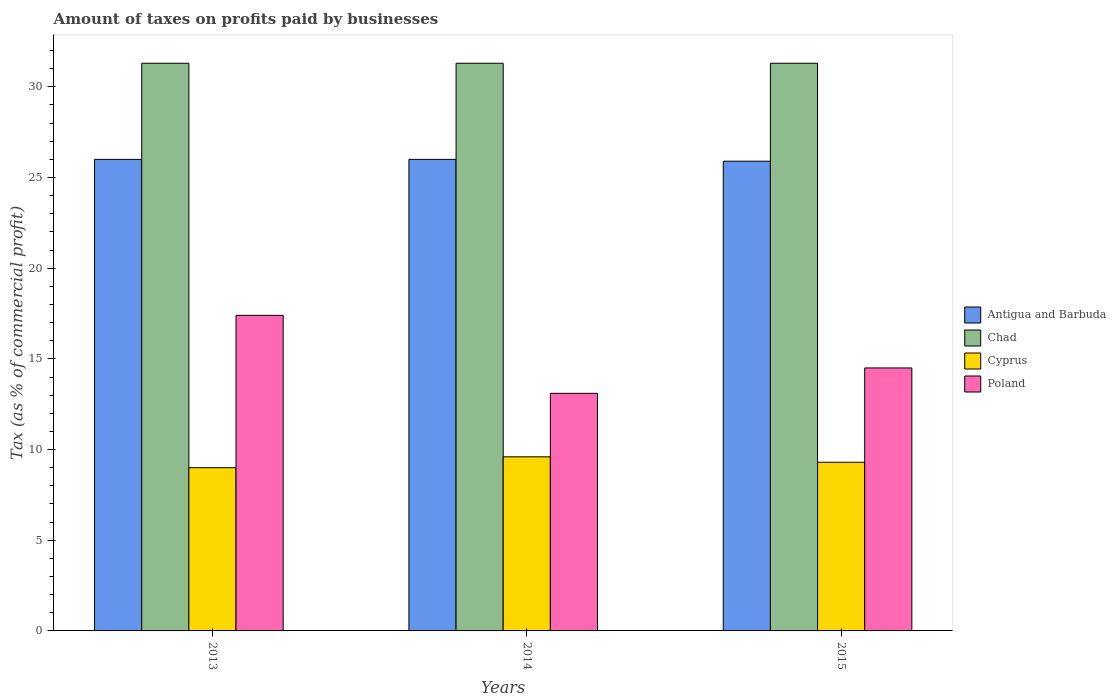How many different coloured bars are there?
Your response must be concise. 4. How many groups of bars are there?
Your answer should be very brief. 3. How many bars are there on the 1st tick from the left?
Offer a terse response. 4. How many bars are there on the 3rd tick from the right?
Offer a very short reply. 4. What is the label of the 2nd group of bars from the left?
Give a very brief answer. 2014. Across all years, what is the maximum percentage of taxes paid by businesses in Chad?
Offer a very short reply. 31.3. Across all years, what is the minimum percentage of taxes paid by businesses in Cyprus?
Provide a short and direct response. 9. In which year was the percentage of taxes paid by businesses in Chad maximum?
Give a very brief answer. 2013. In which year was the percentage of taxes paid by businesses in Cyprus minimum?
Your response must be concise. 2013. What is the total percentage of taxes paid by businesses in Cyprus in the graph?
Provide a succinct answer. 27.9. What is the difference between the percentage of taxes paid by businesses in Poland in 2013 and that in 2015?
Your answer should be very brief. 2.9. What is the difference between the percentage of taxes paid by businesses in Cyprus in 2015 and the percentage of taxes paid by businesses in Antigua and Barbuda in 2014?
Provide a short and direct response. -16.7. What is the average percentage of taxes paid by businesses in Antigua and Barbuda per year?
Ensure brevity in your answer.  25.97. In the year 2013, what is the difference between the percentage of taxes paid by businesses in Cyprus and percentage of taxes paid by businesses in Chad?
Provide a short and direct response. -22.3. In how many years, is the percentage of taxes paid by businesses in Chad greater than 19 %?
Keep it short and to the point. 3. Is the percentage of taxes paid by businesses in Cyprus in 2014 less than that in 2015?
Your answer should be very brief. No. Is the difference between the percentage of taxes paid by businesses in Cyprus in 2013 and 2015 greater than the difference between the percentage of taxes paid by businesses in Chad in 2013 and 2015?
Provide a succinct answer. No. What is the difference between the highest and the second highest percentage of taxes paid by businesses in Cyprus?
Your response must be concise. 0.3. What is the difference between the highest and the lowest percentage of taxes paid by businesses in Cyprus?
Offer a terse response. 0.6. In how many years, is the percentage of taxes paid by businesses in Cyprus greater than the average percentage of taxes paid by businesses in Cyprus taken over all years?
Provide a short and direct response. 1. Is the sum of the percentage of taxes paid by businesses in Antigua and Barbuda in 2014 and 2015 greater than the maximum percentage of taxes paid by businesses in Poland across all years?
Your answer should be compact. Yes. Is it the case that in every year, the sum of the percentage of taxes paid by businesses in Poland and percentage of taxes paid by businesses in Antigua and Barbuda is greater than the sum of percentage of taxes paid by businesses in Chad and percentage of taxes paid by businesses in Cyprus?
Give a very brief answer. No. What does the 2nd bar from the left in 2013 represents?
Offer a very short reply. Chad. What does the 1st bar from the right in 2015 represents?
Provide a short and direct response. Poland. Is it the case that in every year, the sum of the percentage of taxes paid by businesses in Poland and percentage of taxes paid by businesses in Chad is greater than the percentage of taxes paid by businesses in Cyprus?
Your answer should be compact. Yes. How many bars are there?
Your answer should be very brief. 12. What is the difference between two consecutive major ticks on the Y-axis?
Offer a terse response. 5. Are the values on the major ticks of Y-axis written in scientific E-notation?
Keep it short and to the point. No. Where does the legend appear in the graph?
Give a very brief answer. Center right. What is the title of the graph?
Ensure brevity in your answer.  Amount of taxes on profits paid by businesses. Does "Turks and Caicos Islands" appear as one of the legend labels in the graph?
Your answer should be compact. No. What is the label or title of the X-axis?
Your response must be concise. Years. What is the label or title of the Y-axis?
Provide a short and direct response. Tax (as % of commercial profit). What is the Tax (as % of commercial profit) of Chad in 2013?
Provide a succinct answer. 31.3. What is the Tax (as % of commercial profit) of Poland in 2013?
Keep it short and to the point. 17.4. What is the Tax (as % of commercial profit) of Chad in 2014?
Your answer should be very brief. 31.3. What is the Tax (as % of commercial profit) of Cyprus in 2014?
Your answer should be compact. 9.6. What is the Tax (as % of commercial profit) of Antigua and Barbuda in 2015?
Your answer should be compact. 25.9. What is the Tax (as % of commercial profit) of Chad in 2015?
Give a very brief answer. 31.3. What is the Tax (as % of commercial profit) in Cyprus in 2015?
Offer a terse response. 9.3. Across all years, what is the maximum Tax (as % of commercial profit) of Chad?
Give a very brief answer. 31.3. Across all years, what is the maximum Tax (as % of commercial profit) of Cyprus?
Offer a very short reply. 9.6. Across all years, what is the minimum Tax (as % of commercial profit) of Antigua and Barbuda?
Offer a terse response. 25.9. Across all years, what is the minimum Tax (as % of commercial profit) of Chad?
Offer a terse response. 31.3. Across all years, what is the minimum Tax (as % of commercial profit) of Poland?
Your answer should be very brief. 13.1. What is the total Tax (as % of commercial profit) in Antigua and Barbuda in the graph?
Your response must be concise. 77.9. What is the total Tax (as % of commercial profit) in Chad in the graph?
Offer a terse response. 93.9. What is the total Tax (as % of commercial profit) in Cyprus in the graph?
Provide a short and direct response. 27.9. What is the difference between the Tax (as % of commercial profit) of Chad in 2013 and that in 2014?
Your answer should be very brief. 0. What is the difference between the Tax (as % of commercial profit) in Antigua and Barbuda in 2013 and that in 2015?
Your answer should be very brief. 0.1. What is the difference between the Tax (as % of commercial profit) of Chad in 2013 and that in 2015?
Your answer should be compact. 0. What is the difference between the Tax (as % of commercial profit) of Cyprus in 2013 and that in 2015?
Make the answer very short. -0.3. What is the difference between the Tax (as % of commercial profit) in Antigua and Barbuda in 2014 and that in 2015?
Offer a very short reply. 0.1. What is the difference between the Tax (as % of commercial profit) of Cyprus in 2014 and that in 2015?
Provide a short and direct response. 0.3. What is the difference between the Tax (as % of commercial profit) in Poland in 2014 and that in 2015?
Make the answer very short. -1.4. What is the difference between the Tax (as % of commercial profit) in Antigua and Barbuda in 2013 and the Tax (as % of commercial profit) in Poland in 2014?
Give a very brief answer. 12.9. What is the difference between the Tax (as % of commercial profit) in Chad in 2013 and the Tax (as % of commercial profit) in Cyprus in 2014?
Keep it short and to the point. 21.7. What is the difference between the Tax (as % of commercial profit) of Chad in 2013 and the Tax (as % of commercial profit) of Poland in 2014?
Ensure brevity in your answer.  18.2. What is the difference between the Tax (as % of commercial profit) in Cyprus in 2013 and the Tax (as % of commercial profit) in Poland in 2014?
Your answer should be very brief. -4.1. What is the difference between the Tax (as % of commercial profit) in Antigua and Barbuda in 2013 and the Tax (as % of commercial profit) in Cyprus in 2015?
Keep it short and to the point. 16.7. What is the difference between the Tax (as % of commercial profit) in Cyprus in 2013 and the Tax (as % of commercial profit) in Poland in 2015?
Offer a very short reply. -5.5. What is the difference between the Tax (as % of commercial profit) of Antigua and Barbuda in 2014 and the Tax (as % of commercial profit) of Chad in 2015?
Provide a short and direct response. -5.3. What is the difference between the Tax (as % of commercial profit) in Antigua and Barbuda in 2014 and the Tax (as % of commercial profit) in Cyprus in 2015?
Offer a terse response. 16.7. What is the average Tax (as % of commercial profit) of Antigua and Barbuda per year?
Make the answer very short. 25.97. What is the average Tax (as % of commercial profit) in Chad per year?
Provide a short and direct response. 31.3. What is the average Tax (as % of commercial profit) of Poland per year?
Keep it short and to the point. 15. In the year 2013, what is the difference between the Tax (as % of commercial profit) in Antigua and Barbuda and Tax (as % of commercial profit) in Chad?
Provide a succinct answer. -5.3. In the year 2013, what is the difference between the Tax (as % of commercial profit) of Chad and Tax (as % of commercial profit) of Cyprus?
Provide a succinct answer. 22.3. In the year 2013, what is the difference between the Tax (as % of commercial profit) in Chad and Tax (as % of commercial profit) in Poland?
Your answer should be compact. 13.9. In the year 2013, what is the difference between the Tax (as % of commercial profit) in Cyprus and Tax (as % of commercial profit) in Poland?
Offer a very short reply. -8.4. In the year 2014, what is the difference between the Tax (as % of commercial profit) in Antigua and Barbuda and Tax (as % of commercial profit) in Cyprus?
Keep it short and to the point. 16.4. In the year 2014, what is the difference between the Tax (as % of commercial profit) in Antigua and Barbuda and Tax (as % of commercial profit) in Poland?
Your response must be concise. 12.9. In the year 2014, what is the difference between the Tax (as % of commercial profit) in Chad and Tax (as % of commercial profit) in Cyprus?
Give a very brief answer. 21.7. In the year 2014, what is the difference between the Tax (as % of commercial profit) of Cyprus and Tax (as % of commercial profit) of Poland?
Your answer should be compact. -3.5. In the year 2015, what is the difference between the Tax (as % of commercial profit) in Antigua and Barbuda and Tax (as % of commercial profit) in Chad?
Give a very brief answer. -5.4. In the year 2015, what is the difference between the Tax (as % of commercial profit) of Antigua and Barbuda and Tax (as % of commercial profit) of Cyprus?
Provide a succinct answer. 16.6. In the year 2015, what is the difference between the Tax (as % of commercial profit) in Antigua and Barbuda and Tax (as % of commercial profit) in Poland?
Your answer should be very brief. 11.4. In the year 2015, what is the difference between the Tax (as % of commercial profit) in Chad and Tax (as % of commercial profit) in Poland?
Keep it short and to the point. 16.8. In the year 2015, what is the difference between the Tax (as % of commercial profit) in Cyprus and Tax (as % of commercial profit) in Poland?
Your answer should be very brief. -5.2. What is the ratio of the Tax (as % of commercial profit) in Antigua and Barbuda in 2013 to that in 2014?
Your answer should be compact. 1. What is the ratio of the Tax (as % of commercial profit) of Cyprus in 2013 to that in 2014?
Keep it short and to the point. 0.94. What is the ratio of the Tax (as % of commercial profit) of Poland in 2013 to that in 2014?
Your response must be concise. 1.33. What is the ratio of the Tax (as % of commercial profit) of Chad in 2013 to that in 2015?
Offer a terse response. 1. What is the ratio of the Tax (as % of commercial profit) of Poland in 2013 to that in 2015?
Make the answer very short. 1.2. What is the ratio of the Tax (as % of commercial profit) in Antigua and Barbuda in 2014 to that in 2015?
Give a very brief answer. 1. What is the ratio of the Tax (as % of commercial profit) in Cyprus in 2014 to that in 2015?
Provide a succinct answer. 1.03. What is the ratio of the Tax (as % of commercial profit) in Poland in 2014 to that in 2015?
Provide a succinct answer. 0.9. What is the difference between the highest and the second highest Tax (as % of commercial profit) of Chad?
Your answer should be very brief. 0. What is the difference between the highest and the second highest Tax (as % of commercial profit) of Cyprus?
Keep it short and to the point. 0.3. What is the difference between the highest and the second highest Tax (as % of commercial profit) of Poland?
Ensure brevity in your answer.  2.9. What is the difference between the highest and the lowest Tax (as % of commercial profit) of Chad?
Offer a very short reply. 0. 